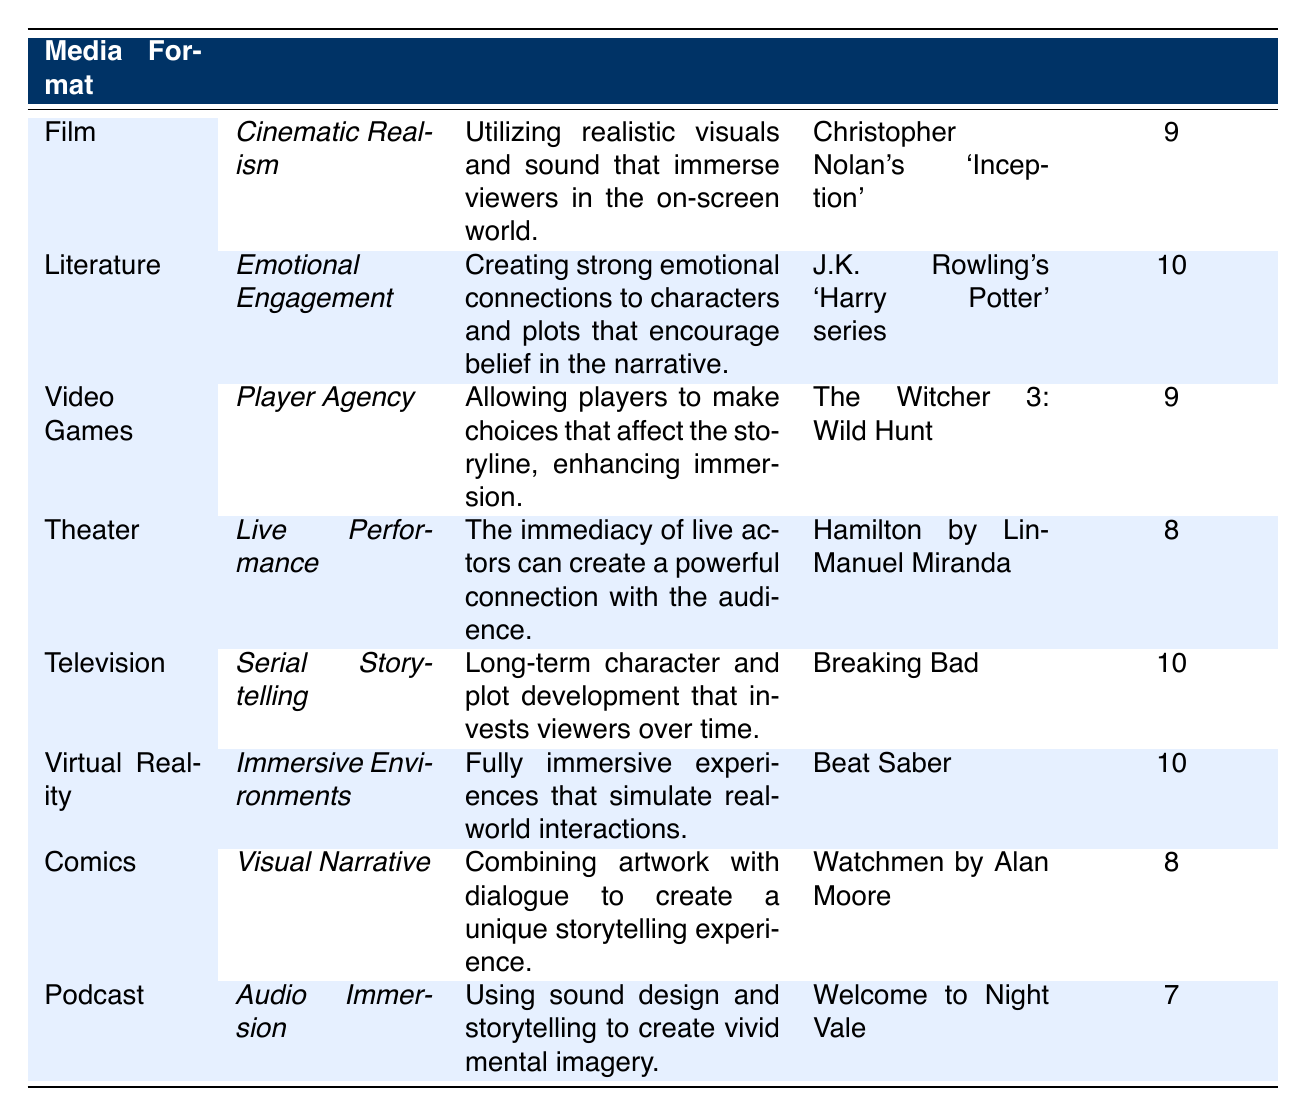What is the effectiveness rating for the technique used in Literature? According to the table, the effectiveness rating for "Emotional Engagement" in Literature is 10.
Answer: 10 Which media format has the technique "Player Agency"? The table indicates that "Player Agency" is the technique used in Video Games.
Answer: Video Games List the example associated with the technique "Cinematic Realism." The example given for the technique "Cinematic Realism" in Film is Christopher Nolan's 'Inception.'
Answer: Christopher Nolan's 'Inception' Is "Serial Storytelling" the most effective technique among all listed? "Serial Storytelling" has an effectiveness rating of 10, which is shared with other techniques like "Emotional Engagement," "Virtual Reality," and "Immersive Environments." Therefore, it is not the only most effective technique.
Answer: No What is the average effectiveness rating for the techniques listed in Theater and Podcast? The effectiveness rating for Theater (Live Performance) is 8, and for Podcast (Audio Immersion) it is 7. The average is (8 + 7) / 2 = 7.5.
Answer: 7.5 Which technique has a higher effectiveness rating: "Visual Narrative" or "Audio Immersion"? "Visual Narrative" has an effectiveness rating of 8, whereas "Audio Immersion" has a rating of 7, making "Visual Narrative" the technique with the higher rating.
Answer: Visual Narrative Calculate the total effectiveness rating for all media formats listed. The total effectiveness ratings are 9 + 10 + 9 + 8 + 10 + 10 + 8 + 7 = 71.
Answer: 71 What percentage of the techniques have an effectiveness rating of 10? There are 8 techniques total, and 4 of them (Literature, Television, Virtual Reality, and the second instance of effectiveness at 10) have a rating of 10. The percentage is (4/8) * 100 = 50%.
Answer: 50% 